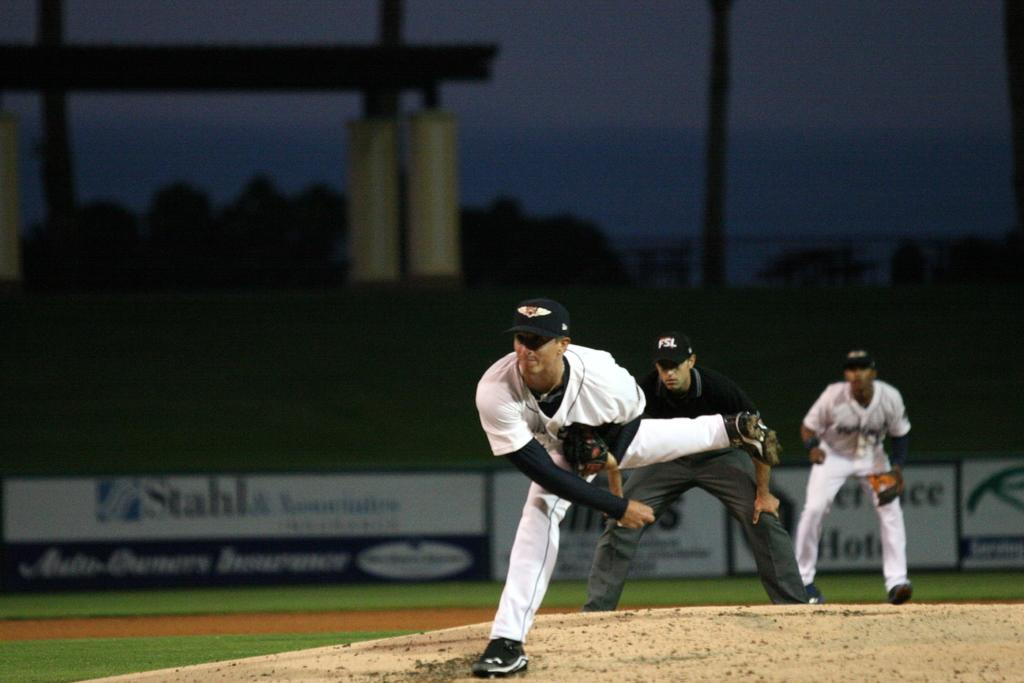<image>
Relay a brief, clear account of the picture shown. A Stahl billboard rings the baseball field during twilight. 